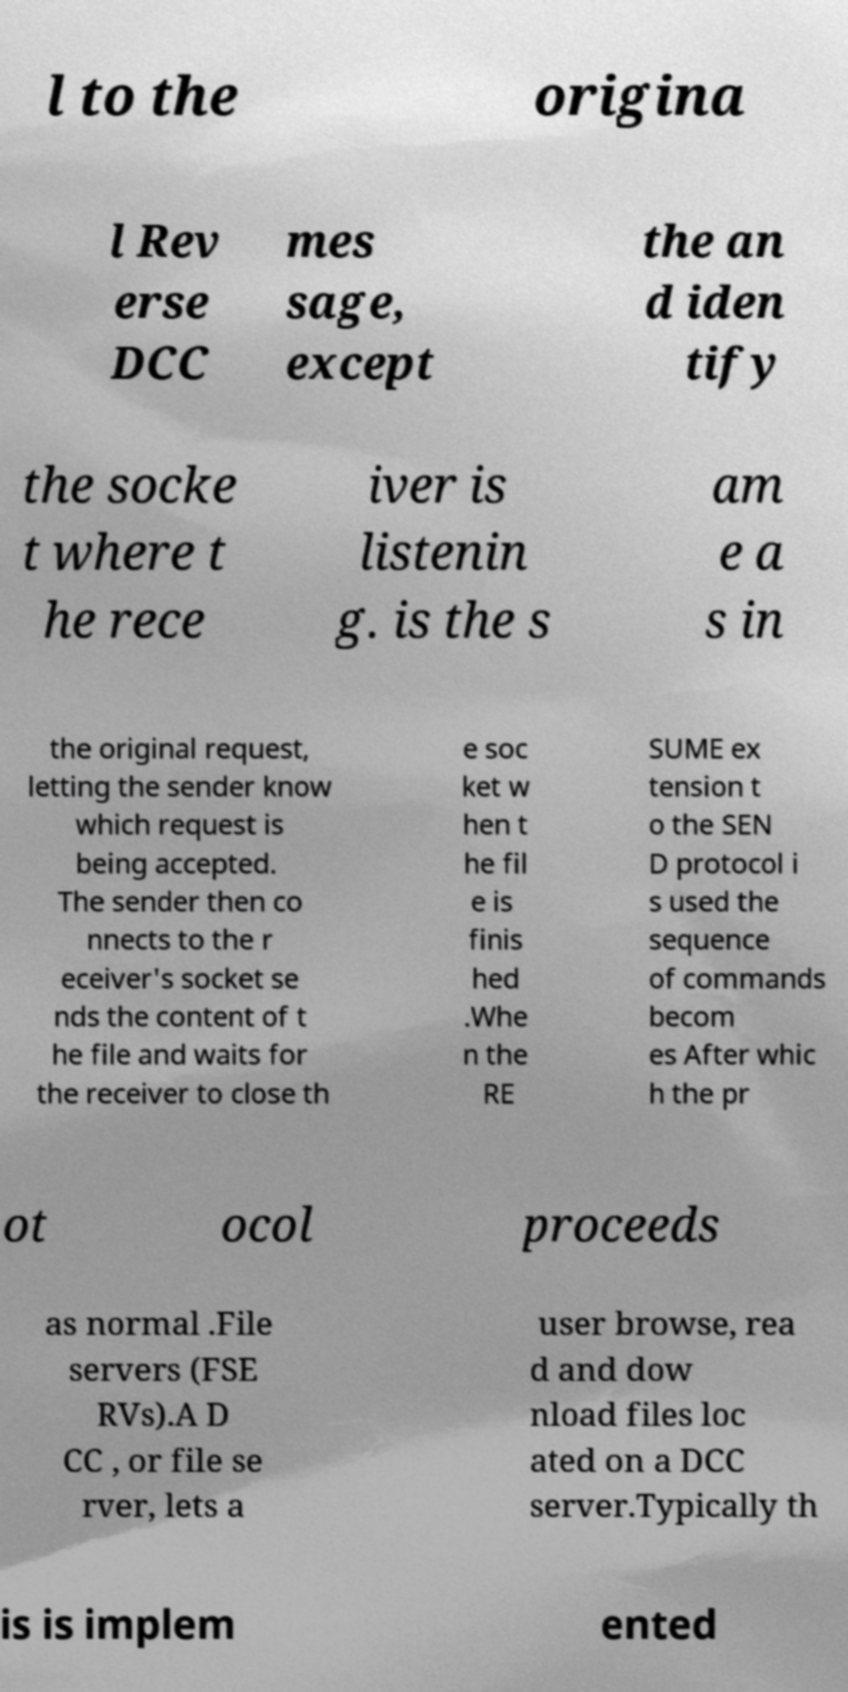Please read and relay the text visible in this image. What does it say? l to the origina l Rev erse DCC mes sage, except the an d iden tify the socke t where t he rece iver is listenin g. is the s am e a s in the original request, letting the sender know which request is being accepted. The sender then co nnects to the r eceiver's socket se nds the content of t he file and waits for the receiver to close th e soc ket w hen t he fil e is finis hed .Whe n the RE SUME ex tension t o the SEN D protocol i s used the sequence of commands becom es After whic h the pr ot ocol proceeds as normal .File servers (FSE RVs).A D CC , or file se rver, lets a user browse, rea d and dow nload files loc ated on a DCC server.Typically th is is implem ented 